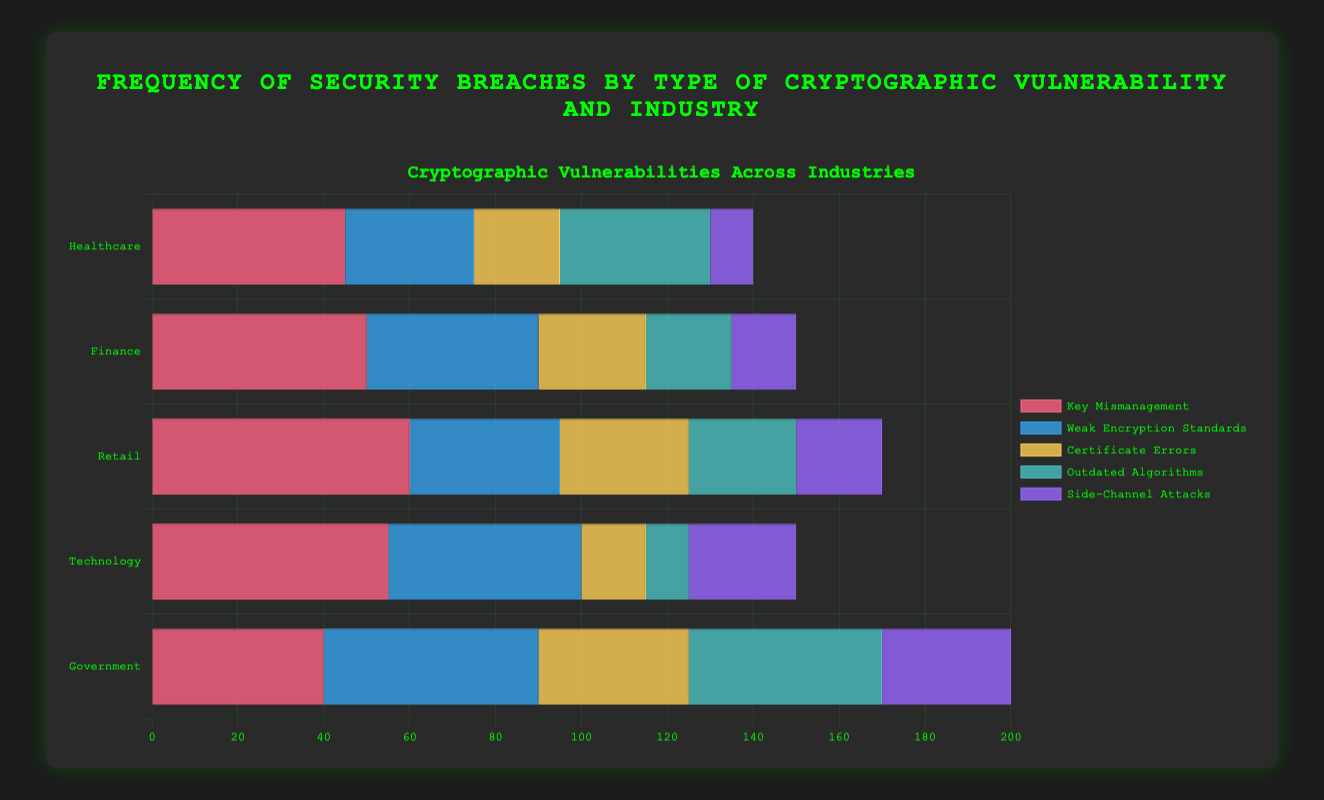Which industry has the highest frequency of Key Mismanagement breaches? According to the bar chart, the Retail industry has the highest frequency of breaches due to Key Mismanagement, with 60 occurrences.
Answer: Retail In which industry do Weak Encryption Standards cause the most breaches? By examining the chart, we can see that the Government industry has the highest frequency of breaches caused by Weak Encryption Standards, with 50 occurrences.
Answer: Government What is the difference in the number of breaches due to Certificate Errors between Healthcare and Technology industries? The Healthcare industry has 20 breaches due to Certificate Errors, and the Technology industry has 15 breaches. The difference is 20 - 15 = 5 breaches.
Answer: 5 How many total breaches are recorded for the Technology industry? Summing up all the types of breaches for the Technology industry gives 55 (Key Mismanagement) + 45 (Weak Encryption Standards) + 15 (Certificate Errors) + 10 (Outdated Algorithms) + 25 (Side-Channel Attacks) = 150 breaches.
Answer: 150 Which cryptographic vulnerability has the least frequency across all industries? Side-Channel Attacks have the lowest frequency in all industries combined, with individual industry frequencies as follows: Healthcare (10), Finance (15), Retail (20), Technology (25), Government (30).
Answer: Side-Channel Attacks What is the average number of breaches due to Outdated Algorithms across all industries? By summing the breaches due to Outdated Algorithms in all industries: Healthcare (35), Finance (20), Retail (25), Technology (10), Government (45), we get a total of 35 + 20 + 25 + 10 + 45 = 135. Dividing by 5 (the number of industries), the average is 135 / 5 = 27.
Answer: 27 Are there more breaches in the Healthcare or Finance industry for Weak Encryption Standards? Referring to the bar chart, the Healthcare industry records 30 breaches due to Weak Encryption Standards, while the Finance industry records 40 breaches. Therefore, the Finance industry has more breaches.
Answer: Finance What is the total number of breaches due to Key Mismanagement in Healthcare and Retail industries combined? Summing the breaches in Healthcare and Retail due to Key Mismanagement: Healthcare (45) + Retail (60) = 105 breaches.
Answer: 105 Which industry sees the highest number of breaches due to Certificate Errors, and what is that number? The Government industry has the highest number of breaches caused by Certificate Errors, with a total of 35 breaches.
Answer: Government 